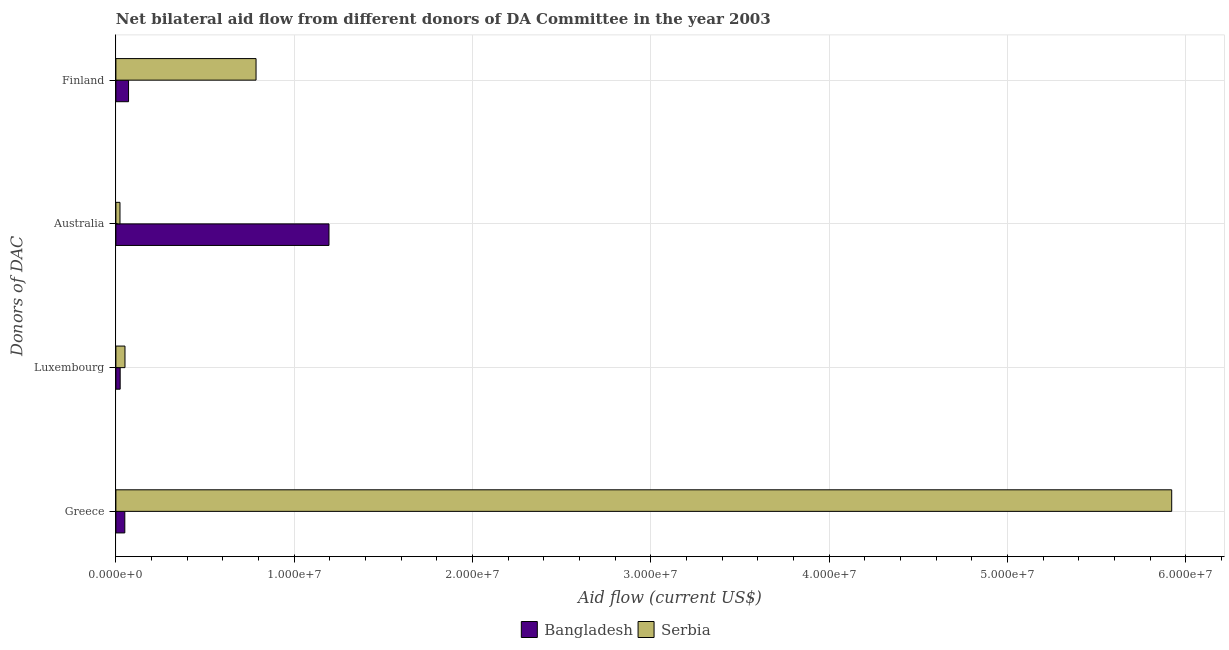How many different coloured bars are there?
Your answer should be compact. 2. How many groups of bars are there?
Ensure brevity in your answer.  4. How many bars are there on the 1st tick from the bottom?
Offer a very short reply. 2. What is the label of the 3rd group of bars from the top?
Ensure brevity in your answer.  Luxembourg. What is the amount of aid given by greece in Serbia?
Keep it short and to the point. 5.92e+07. Across all countries, what is the maximum amount of aid given by greece?
Keep it short and to the point. 5.92e+07. Across all countries, what is the minimum amount of aid given by greece?
Provide a succinct answer. 5.00e+05. In which country was the amount of aid given by luxembourg maximum?
Offer a terse response. Serbia. What is the total amount of aid given by finland in the graph?
Provide a succinct answer. 8.57e+06. What is the difference between the amount of aid given by finland in Serbia and that in Bangladesh?
Offer a very short reply. 7.15e+06. What is the difference between the amount of aid given by greece in Bangladesh and the amount of aid given by finland in Serbia?
Make the answer very short. -7.36e+06. What is the average amount of aid given by finland per country?
Your answer should be compact. 4.28e+06. What is the difference between the amount of aid given by greece and amount of aid given by luxembourg in Bangladesh?
Make the answer very short. 2.60e+05. What is the ratio of the amount of aid given by finland in Serbia to that in Bangladesh?
Keep it short and to the point. 11.07. What is the difference between the highest and the second highest amount of aid given by australia?
Your answer should be very brief. 1.17e+07. What is the difference between the highest and the lowest amount of aid given by luxembourg?
Your answer should be compact. 2.70e+05. In how many countries, is the amount of aid given by finland greater than the average amount of aid given by finland taken over all countries?
Your response must be concise. 1. What does the 1st bar from the top in Luxembourg represents?
Your answer should be very brief. Serbia. What does the 2nd bar from the bottom in Finland represents?
Your answer should be compact. Serbia. Is it the case that in every country, the sum of the amount of aid given by greece and amount of aid given by luxembourg is greater than the amount of aid given by australia?
Keep it short and to the point. No. Are all the bars in the graph horizontal?
Your answer should be very brief. Yes. How many countries are there in the graph?
Offer a terse response. 2. What is the difference between two consecutive major ticks on the X-axis?
Offer a terse response. 1.00e+07. Are the values on the major ticks of X-axis written in scientific E-notation?
Your response must be concise. Yes. Does the graph contain any zero values?
Your response must be concise. No. How many legend labels are there?
Keep it short and to the point. 2. What is the title of the graph?
Make the answer very short. Net bilateral aid flow from different donors of DA Committee in the year 2003. Does "Pacific island small states" appear as one of the legend labels in the graph?
Your answer should be compact. No. What is the label or title of the X-axis?
Your response must be concise. Aid flow (current US$). What is the label or title of the Y-axis?
Provide a succinct answer. Donors of DAC. What is the Aid flow (current US$) in Bangladesh in Greece?
Give a very brief answer. 5.00e+05. What is the Aid flow (current US$) in Serbia in Greece?
Ensure brevity in your answer.  5.92e+07. What is the Aid flow (current US$) of Serbia in Luxembourg?
Provide a short and direct response. 5.10e+05. What is the Aid flow (current US$) of Bangladesh in Australia?
Offer a terse response. 1.20e+07. What is the Aid flow (current US$) in Serbia in Australia?
Give a very brief answer. 2.30e+05. What is the Aid flow (current US$) in Bangladesh in Finland?
Offer a very short reply. 7.10e+05. What is the Aid flow (current US$) in Serbia in Finland?
Give a very brief answer. 7.86e+06. Across all Donors of DAC, what is the maximum Aid flow (current US$) in Bangladesh?
Your answer should be compact. 1.20e+07. Across all Donors of DAC, what is the maximum Aid flow (current US$) of Serbia?
Your answer should be compact. 5.92e+07. What is the total Aid flow (current US$) of Bangladesh in the graph?
Ensure brevity in your answer.  1.34e+07. What is the total Aid flow (current US$) of Serbia in the graph?
Your answer should be very brief. 6.78e+07. What is the difference between the Aid flow (current US$) in Serbia in Greece and that in Luxembourg?
Your answer should be compact. 5.87e+07. What is the difference between the Aid flow (current US$) of Bangladesh in Greece and that in Australia?
Provide a short and direct response. -1.14e+07. What is the difference between the Aid flow (current US$) in Serbia in Greece and that in Australia?
Your answer should be very brief. 5.90e+07. What is the difference between the Aid flow (current US$) of Serbia in Greece and that in Finland?
Your answer should be very brief. 5.14e+07. What is the difference between the Aid flow (current US$) in Bangladesh in Luxembourg and that in Australia?
Give a very brief answer. -1.17e+07. What is the difference between the Aid flow (current US$) in Serbia in Luxembourg and that in Australia?
Make the answer very short. 2.80e+05. What is the difference between the Aid flow (current US$) in Bangladesh in Luxembourg and that in Finland?
Offer a very short reply. -4.70e+05. What is the difference between the Aid flow (current US$) of Serbia in Luxembourg and that in Finland?
Provide a succinct answer. -7.35e+06. What is the difference between the Aid flow (current US$) in Bangladesh in Australia and that in Finland?
Keep it short and to the point. 1.12e+07. What is the difference between the Aid flow (current US$) of Serbia in Australia and that in Finland?
Offer a terse response. -7.63e+06. What is the difference between the Aid flow (current US$) in Bangladesh in Greece and the Aid flow (current US$) in Serbia in Luxembourg?
Offer a very short reply. -10000. What is the difference between the Aid flow (current US$) in Bangladesh in Greece and the Aid flow (current US$) in Serbia in Australia?
Your response must be concise. 2.70e+05. What is the difference between the Aid flow (current US$) in Bangladesh in Greece and the Aid flow (current US$) in Serbia in Finland?
Keep it short and to the point. -7.36e+06. What is the difference between the Aid flow (current US$) in Bangladesh in Luxembourg and the Aid flow (current US$) in Serbia in Australia?
Offer a very short reply. 10000. What is the difference between the Aid flow (current US$) in Bangladesh in Luxembourg and the Aid flow (current US$) in Serbia in Finland?
Ensure brevity in your answer.  -7.62e+06. What is the difference between the Aid flow (current US$) of Bangladesh in Australia and the Aid flow (current US$) of Serbia in Finland?
Your response must be concise. 4.09e+06. What is the average Aid flow (current US$) in Bangladesh per Donors of DAC?
Offer a terse response. 3.35e+06. What is the average Aid flow (current US$) of Serbia per Donors of DAC?
Offer a very short reply. 1.70e+07. What is the difference between the Aid flow (current US$) in Bangladesh and Aid flow (current US$) in Serbia in Greece?
Your answer should be very brief. -5.87e+07. What is the difference between the Aid flow (current US$) of Bangladesh and Aid flow (current US$) of Serbia in Australia?
Keep it short and to the point. 1.17e+07. What is the difference between the Aid flow (current US$) of Bangladesh and Aid flow (current US$) of Serbia in Finland?
Ensure brevity in your answer.  -7.15e+06. What is the ratio of the Aid flow (current US$) of Bangladesh in Greece to that in Luxembourg?
Offer a very short reply. 2.08. What is the ratio of the Aid flow (current US$) of Serbia in Greece to that in Luxembourg?
Offer a very short reply. 116.1. What is the ratio of the Aid flow (current US$) of Bangladesh in Greece to that in Australia?
Make the answer very short. 0.04. What is the ratio of the Aid flow (current US$) of Serbia in Greece to that in Australia?
Your answer should be compact. 257.43. What is the ratio of the Aid flow (current US$) in Bangladesh in Greece to that in Finland?
Offer a very short reply. 0.7. What is the ratio of the Aid flow (current US$) in Serbia in Greece to that in Finland?
Provide a succinct answer. 7.53. What is the ratio of the Aid flow (current US$) of Bangladesh in Luxembourg to that in Australia?
Offer a terse response. 0.02. What is the ratio of the Aid flow (current US$) of Serbia in Luxembourg to that in Australia?
Provide a succinct answer. 2.22. What is the ratio of the Aid flow (current US$) in Bangladesh in Luxembourg to that in Finland?
Provide a succinct answer. 0.34. What is the ratio of the Aid flow (current US$) of Serbia in Luxembourg to that in Finland?
Your response must be concise. 0.06. What is the ratio of the Aid flow (current US$) in Bangladesh in Australia to that in Finland?
Offer a terse response. 16.83. What is the ratio of the Aid flow (current US$) of Serbia in Australia to that in Finland?
Your answer should be compact. 0.03. What is the difference between the highest and the second highest Aid flow (current US$) of Bangladesh?
Keep it short and to the point. 1.12e+07. What is the difference between the highest and the second highest Aid flow (current US$) of Serbia?
Offer a very short reply. 5.14e+07. What is the difference between the highest and the lowest Aid flow (current US$) of Bangladesh?
Your response must be concise. 1.17e+07. What is the difference between the highest and the lowest Aid flow (current US$) of Serbia?
Your answer should be compact. 5.90e+07. 